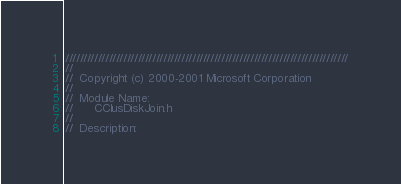<code> <loc_0><loc_0><loc_500><loc_500><_C_>//////////////////////////////////////////////////////////////////////////////
//
//  Copyright (c) 2000-2001 Microsoft Corporation
//
//  Module Name:
//      CClusDiskJoin.h
//
//  Description:</code> 